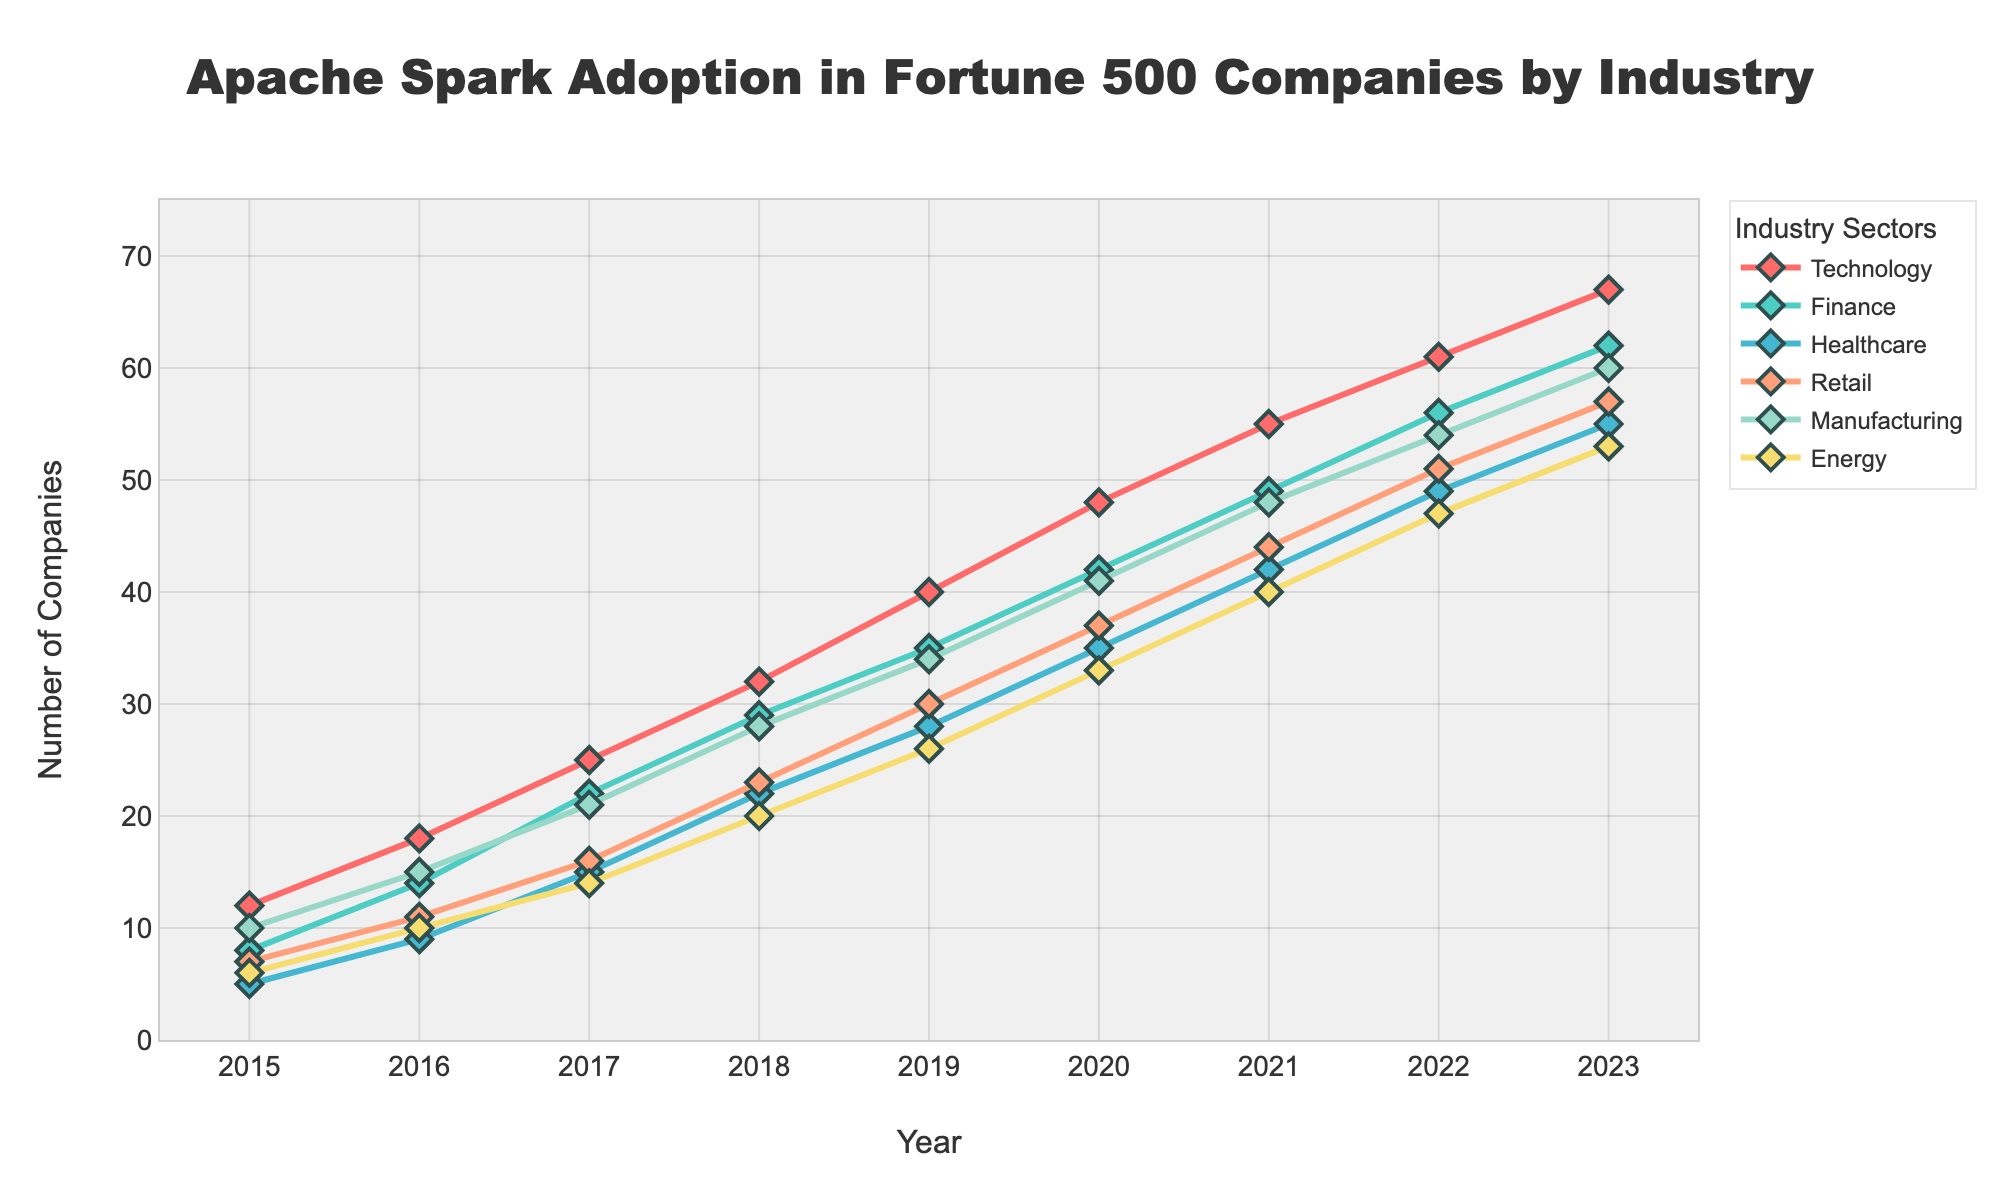What is the adoption trend of Apache Spark in the Finance sector from 2015 to 2023? To determine the adoption trend in the Finance sector, we observe the line representing Finance on the line chart from 2015 to 2023. The trend shows a consistent increase in the number of companies adopting Apache Spark over the years.
Answer: Increasing trend Which sector had the highest number of companies adopting Apache Spark in 2023? We compare the Y-values for all sectors in the year 2023 by looking at the data points. The Retail sector shows the highest value.
Answer: Retail How much did the adoption rate in the Manufacturing sector grow from 2015 to 2023? For the Manufacturing sector, we subtract the value in 2015 (10) from the value in 2023 (60). (60 - 10) = 50.
Answer: 50 Which year saw the largest increase in adoption in the Energy sector? We need to calculate the year-on-year differences for the Energy sector and find the largest. The differences are 4, 4, 6, 6, 6, 7, 7, and 6. The largest increase, 7, happens between 2019 and 2020 and between 2020 and 2021.
Answer: 2019-2020 and 2020-2021 By how many more companies did the adoption rate of Apache Spark in the Finance sector exceed that in the Healthcare sector in 2022? We subtract the Healthcare adoption rate (49) from the Finance adoption rate (61) for the year 2022. (61 - 49) = 12.
Answer: 12 Which sector showed the smallest increase in adoption between 2021 and 2022? By calculating the year-on-year differences for each sector for 2021 to 2022: Technology (6), Finance (6), Healthcare (7), Retail (7), Manufacturing (6), and Energy (7). Technology, Finance, and Manufacturing sectors all showed the smallest increase of 6.
Answer: Technology, Finance, and Manufacturing What is the difference in the number of adopting companies between the Retail and Energy sectors in 2020? We find the values for Retail (41) and Energy (33) in 2020 and calculate the difference. (41 - 33) = 8.
Answer: 8 